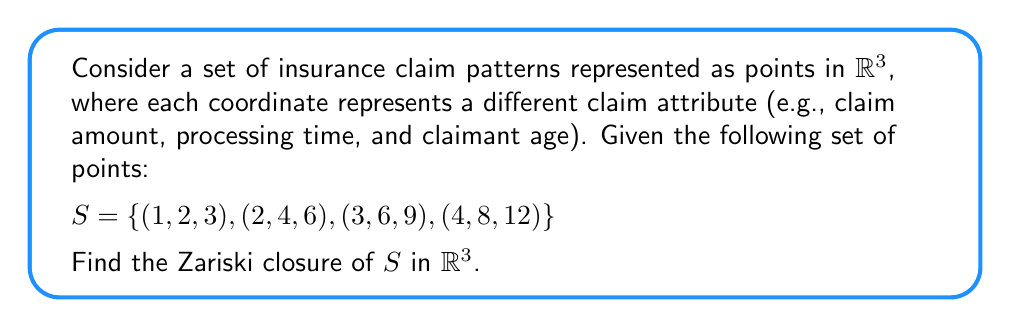Can you answer this question? To find the Zariski closure of the set $S$, we need to follow these steps:

1) First, observe that all points in $S$ lie on a straight line. We can verify this by checking that each point is a scalar multiple of $(1,2,3)$:
   $$(1,2,3), 2(1,2,3), 3(1,2,3), 4(1,2,3)$$

2) The equation of this line can be written parametrically as:
   $$\{(t, 2t, 3t) : t \in \mathbb{R}\}$$

3) To find the Zariski closure, we need to find all polynomials that vanish on $S$. The line equation gives us two such polynomials:
   $$f_1(x,y,z) = y - 2x$$
   $$f_2(x,y,z) = z - 3x$$

4) These polynomials define the ideal $I = \langle y-2x, z-3x \rangle$ in $\mathbb{R}[x,y,z]$.

5) The Zariski closure of $S$ is the zero set of this ideal, which is precisely the line containing all points in $S$.

6) Therefore, the Zariski closure of $S$ is the line:
   $$\{(x,y,z) \in \mathbb{R}^3 : y = 2x \text{ and } z = 3x\}$$

This line represents all possible insurance claim patterns that follow the same relationship between claim amount, processing time, and claimant age as observed in the given data points.
Answer: $\{(x,y,z) \in \mathbb{R}^3 : y = 2x \text{ and } z = 3x\}$ 